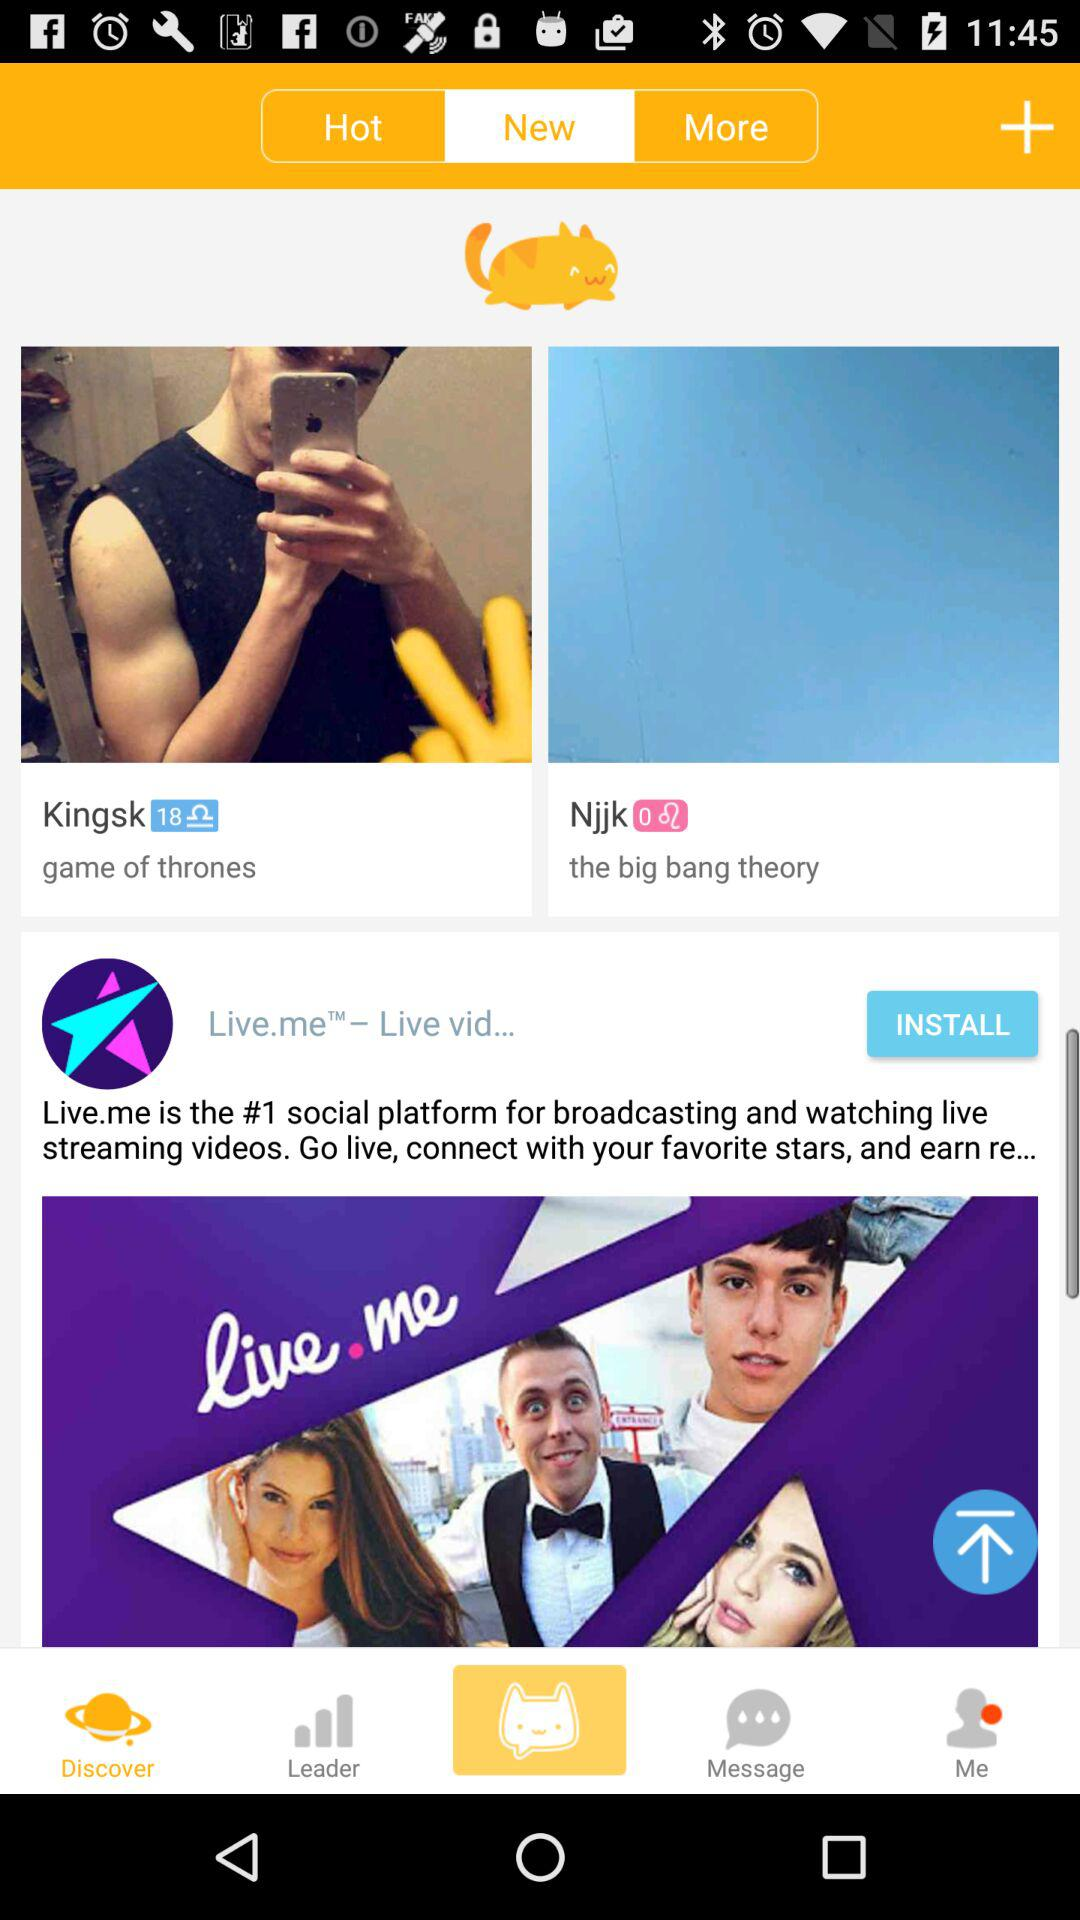What is the total number of permission steps? The total number of permission steps is 6. 